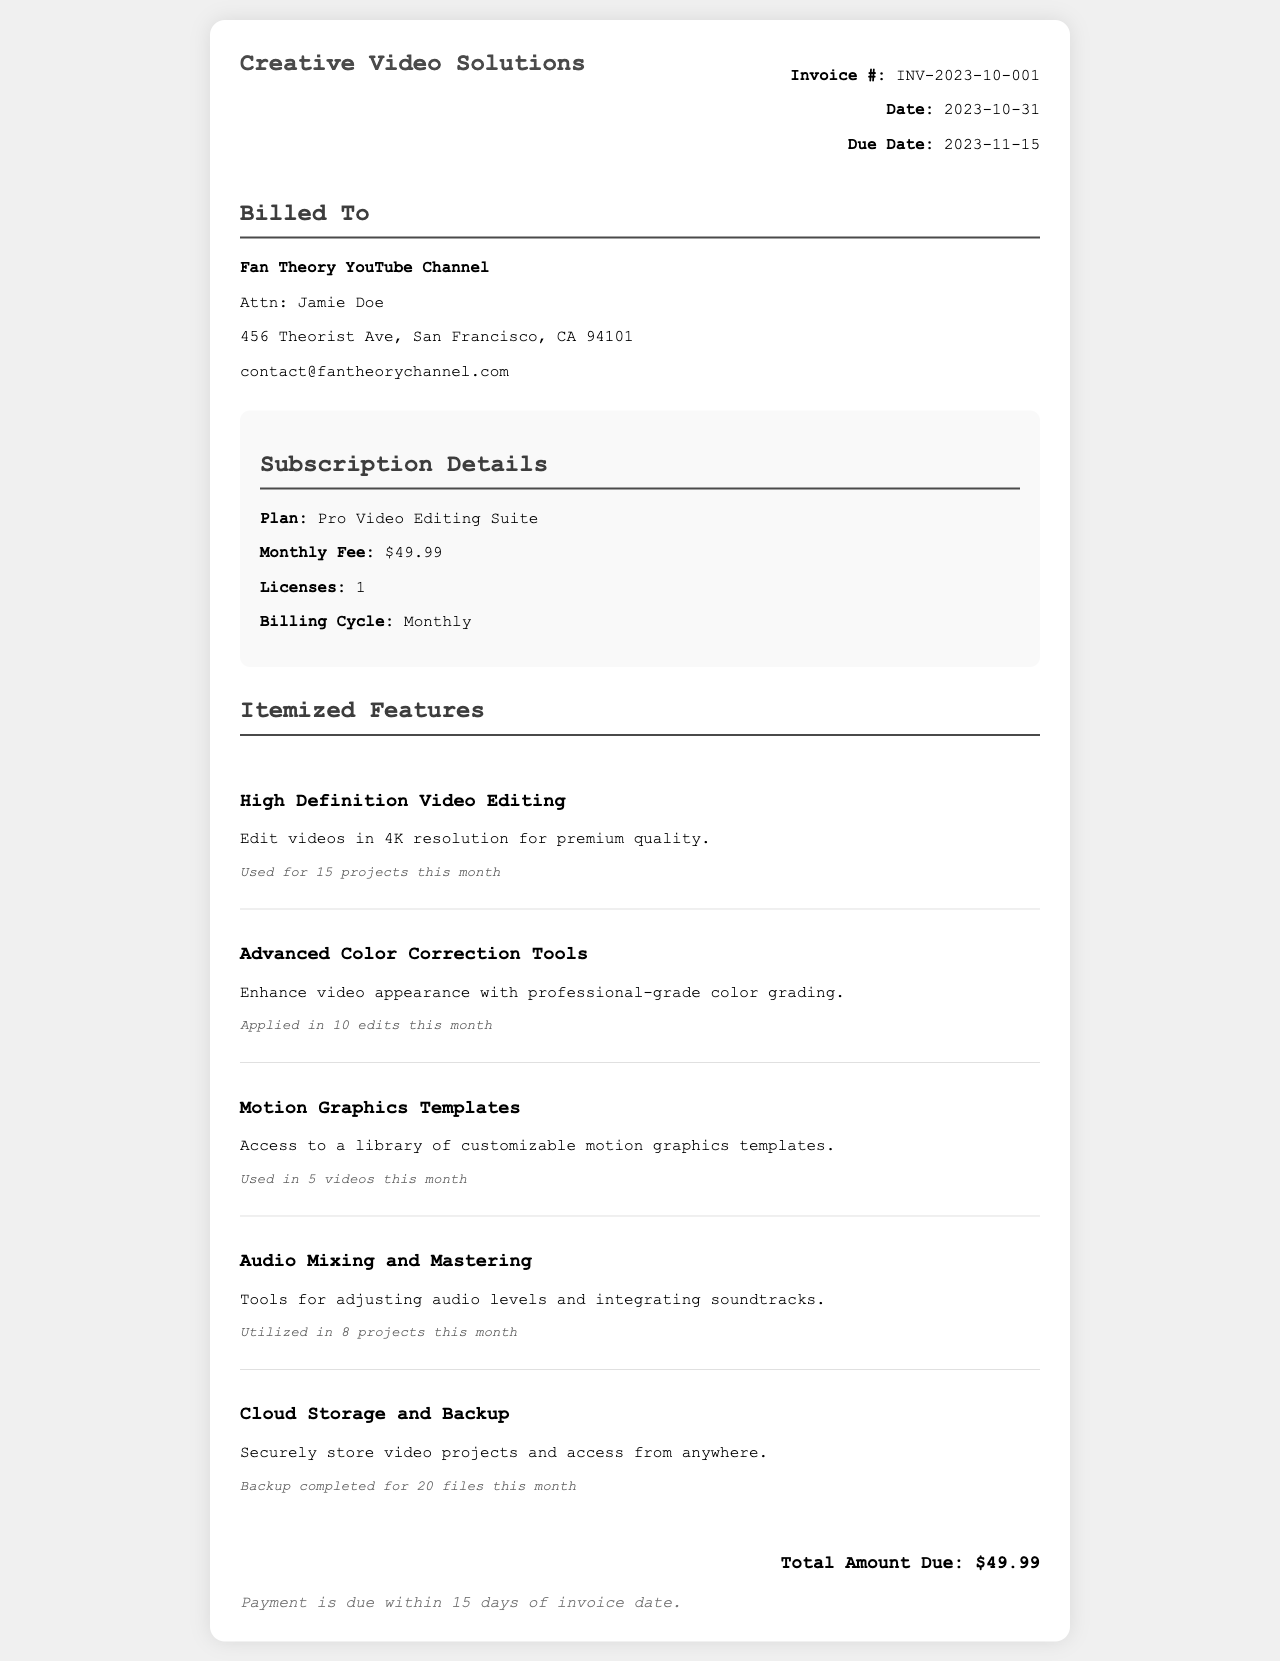what is the invoice number? The invoice number is listed at the top of the document under invoice details.
Answer: INV-2023-10-001 what is the date of the invoice? The date of the invoice is provided in the invoice details section.
Answer: 2023-10-31 what is the monthly fee for the subscription? The monthly fee can be found in the subscription details section of the invoice.
Answer: $49.99 how many licenses are included in the subscription? The number of licenses is stated in the subscription details.
Answer: 1 how many projects used the High Definition Video Editing feature this month? This information is listed under the itemized feature description for High Definition Video Editing.
Answer: 15 projects what features were utilized in 8 projects this month? The details of features used can be found in the itemized features list.
Answer: Audio Mixing and Mastering what is the due date for the payment? The due date is indicated in the invoice details section.
Answer: 2023-11-15 what is the total amount due? The total amount due is specified at the bottom of the invoice.
Answer: $49.99 what is the billing cycle for the subscription? The billing cycle can be found in the subscription details.
Answer: Monthly 